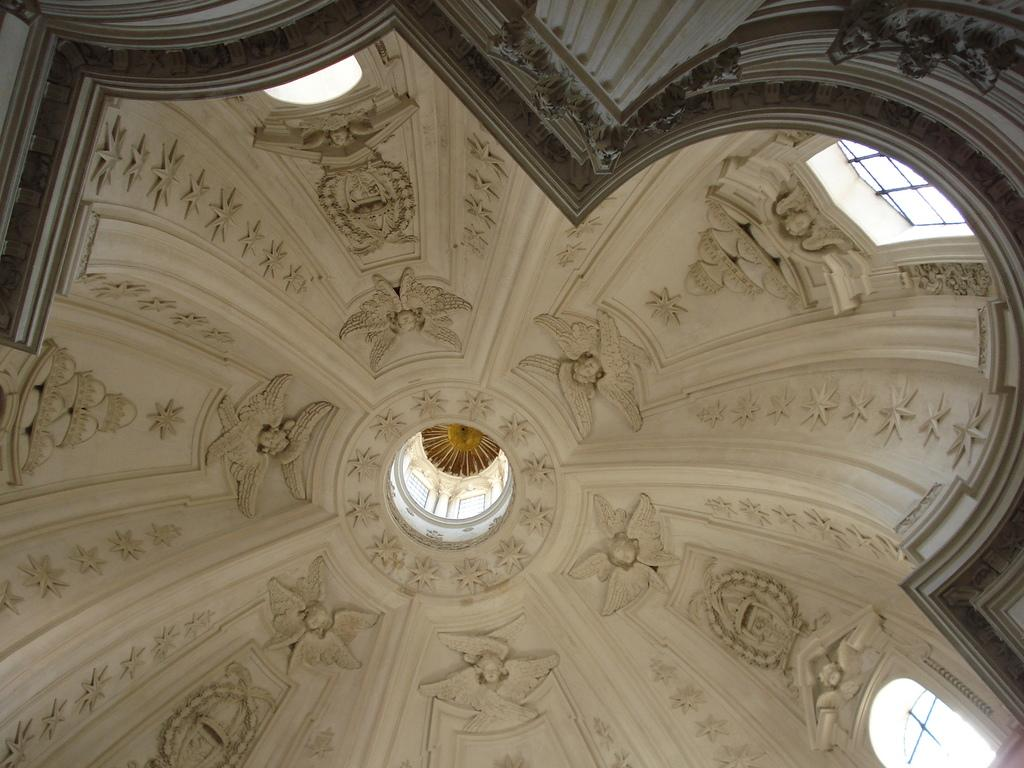What is present above the room in the image? There is a ceiling in the image. What can be seen on the ceiling? There is a sculpture on the ceiling. What architectural feature is visible in the image? There is a pillar in the image. What surrounds the room in the image? There is a wall in the image. What type of plate is being used to serve the sculpture on the ceiling? There is no plate present in the image, as the sculpture is directly on the ceiling. What is the selection of opinions about the sculpture in the image? The image does not provide any opinions about the sculpture; it only shows the sculpture on the ceiling. 